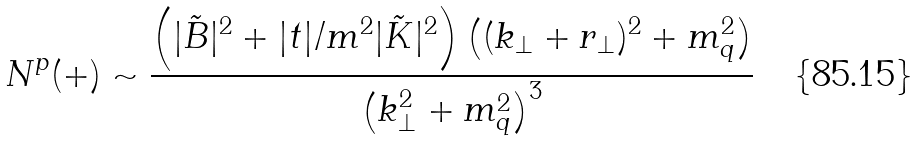<formula> <loc_0><loc_0><loc_500><loc_500>N ^ { p } ( + ) \sim \frac { \left ( | \tilde { B } | ^ { 2 } + | t | / m ^ { 2 } | \tilde { K } | ^ { 2 } \right ) \left ( ( k _ { \perp } + r _ { \perp } ) ^ { 2 } + m _ { q } ^ { 2 } \right ) } { \left ( k _ { \perp } ^ { 2 } + m _ { q } ^ { 2 } \right ) ^ { 3 } }</formula> 